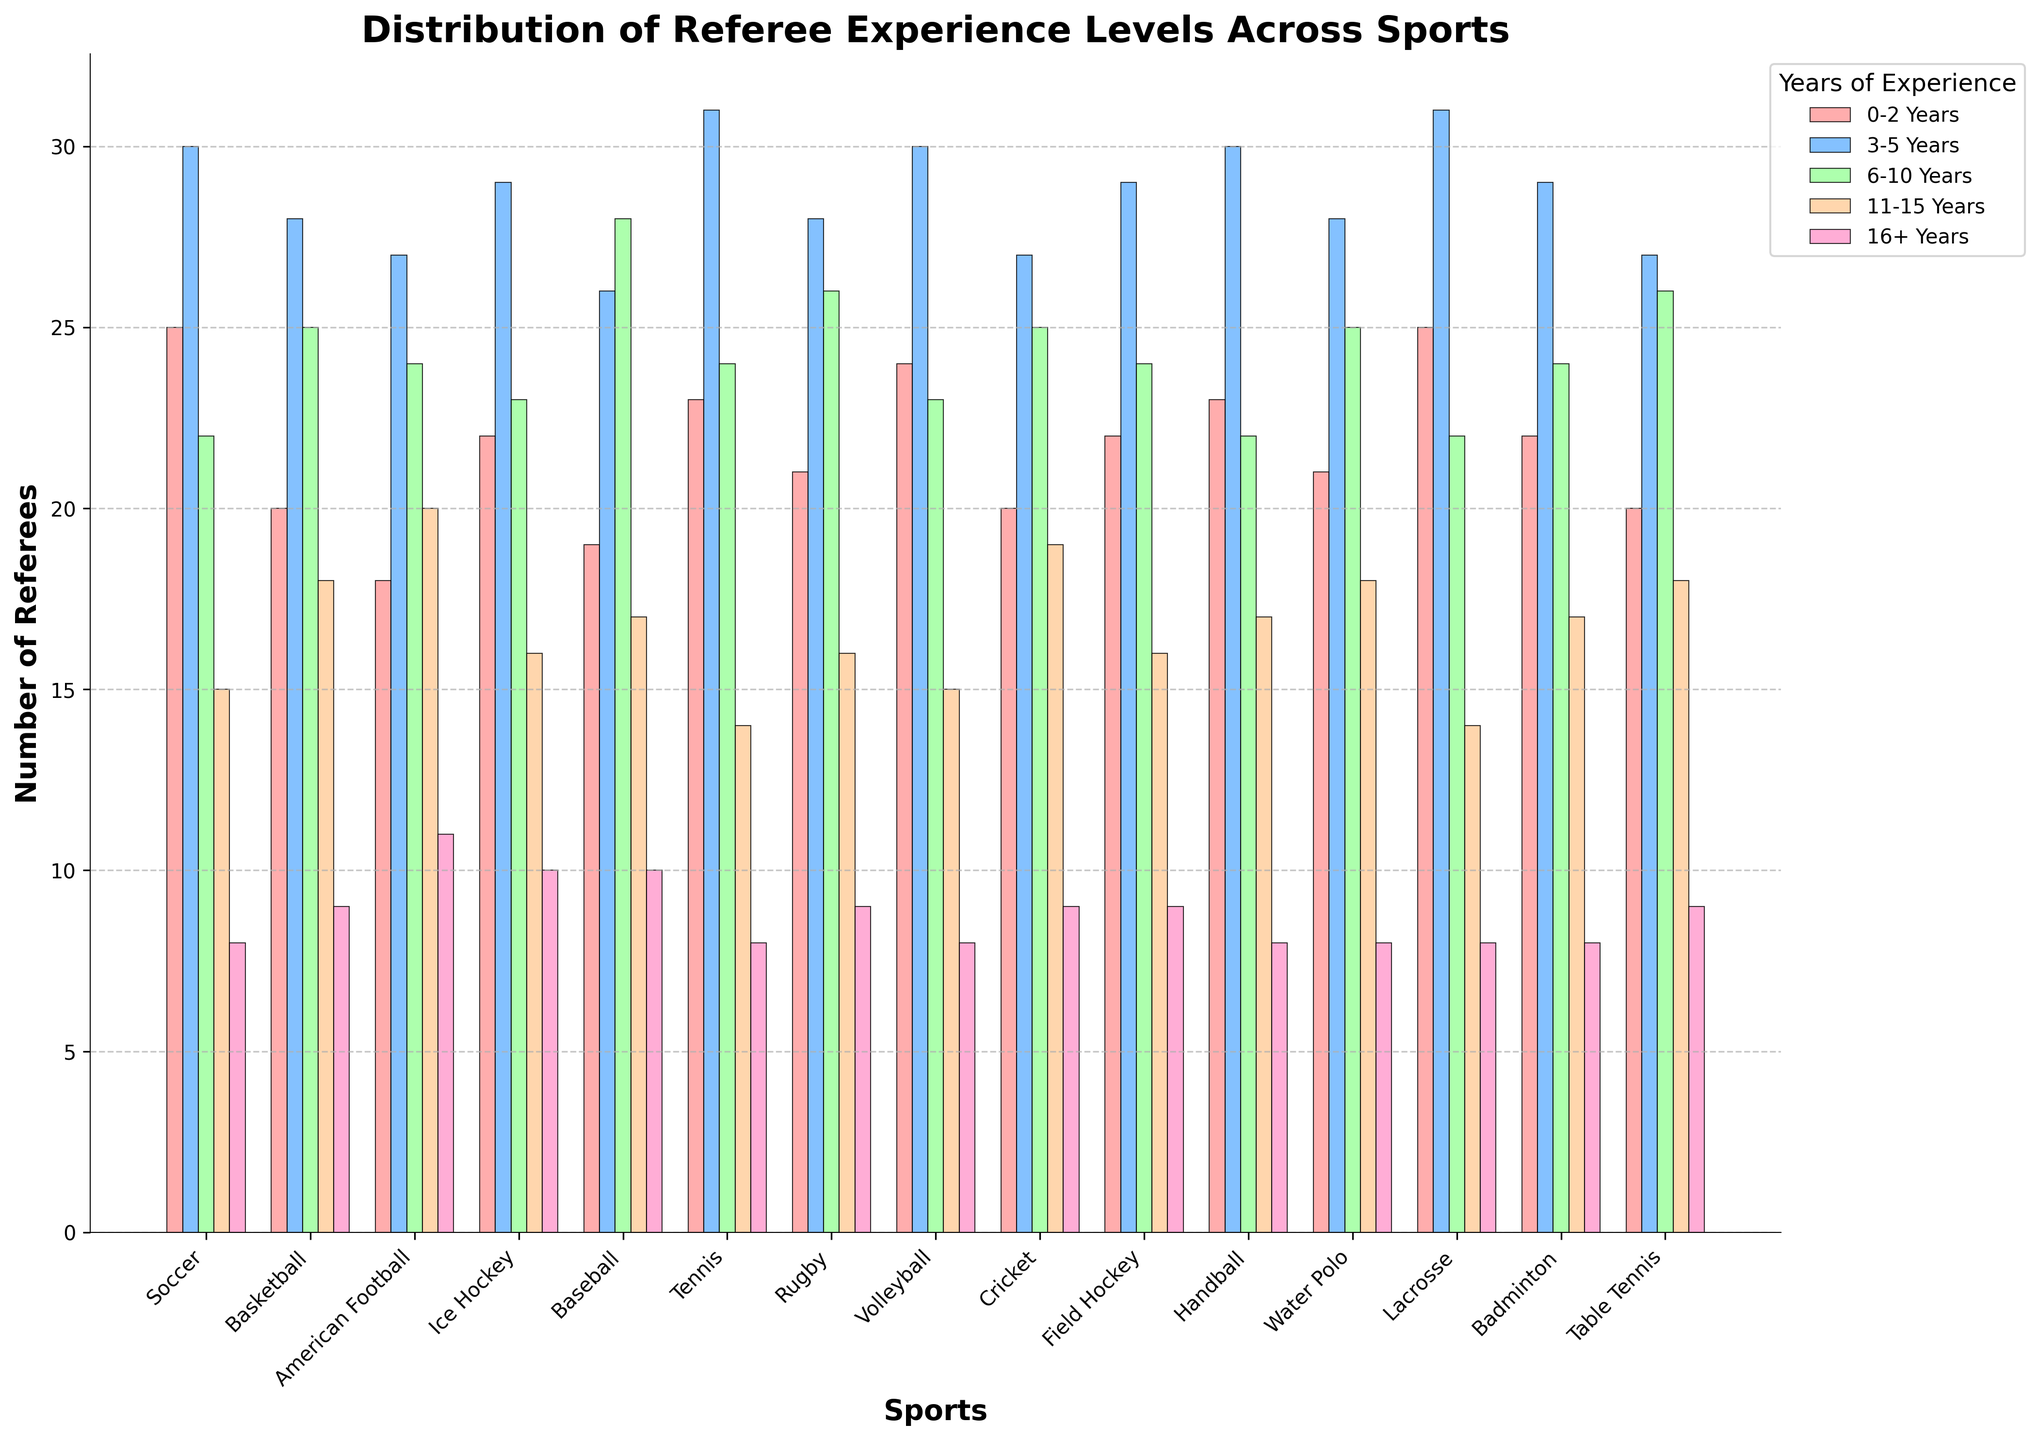What's the sport with the highest number of referees with 0-2 years of experience? Looking at the first (leftmost) set of bars for each sport, the tallest bar represents the sport with the highest number of referees with 0-2 years of experience. Lacrosse has the tallest bar.
Answer: Lacrosse Which sport has the most experienced referees (16+ years)? To determine this, look at the rightmost bars for each sport (the 16+ years category). American Football has the tallest bar in this category.
Answer: American Football How do the number of referees with 3-5 years of experience in basketball compare to those in volleyball? Find the bars representing the 3-5 years category for basketball and volleyball, and compare their heights. Basketball has 28 referees, while Volleyball has 30, so volleyball has more.
Answer: Volleyball What is the total number of referees in soccer across all experience levels? Sum the values for soccer across all experience levels: 25 (0-2) + 30 (3-5) + 22 (6-10) + 15 (11-15) + 8 (16+). Calculating this, we get 100 referees in total.
Answer: 100 Which sport has the lowest number of referees in the 11-15 years of experience category? Looking at the fourth set of bars (11-15 years) for each sport, compare the heights. Lacrosse and Tennis both have the shortest bars with 14 referees.
Answer: Lacrosse and Tennis Which two sports have an equal number of referees with 6-10 years of experience, and what's that number? Look at the bars representing the 6-10 years category for all sports and identify those with the same height. Soccer, Ice Hockey, Volleyball, Lacrosse have 22 referees each in this category.
Answer: Soccer, Ice Hockey, Volleyball, Lacrosse; 22 For Baseball, what's the total number of referees with over 10 years of experience? Add the values for the 11-15 and 16+ years categories in Baseball: 17 (11-15) + 10 (16+). The sum is 27.
Answer: 27 What's the average number of 3-5 year experienced referees across all sports? Add the values for 3-5 years across all sports and then divide by the number of sports. The sum is 449, and there are 15 sports. The average is 449 / 15 ≈ 29.93.
Answer: ~29.93 Is the number of referees with 0-2 years of experience in Badminton greater than in Field Hockey? Compare the bars for the 0-2 years category in Badminton and Field Hockey. Badminton has 22, and Field Hockey has 22, so they are equal.
Answer: No In which sport is the number of referees with 0-2 years of experience the same as the number with 6-10 years of experience, if any? Look for sports where the bars for 0-2 years and 6-10 years are of equal height. In Table Tennis, both have 20 referees.
Answer: Table Tennis 